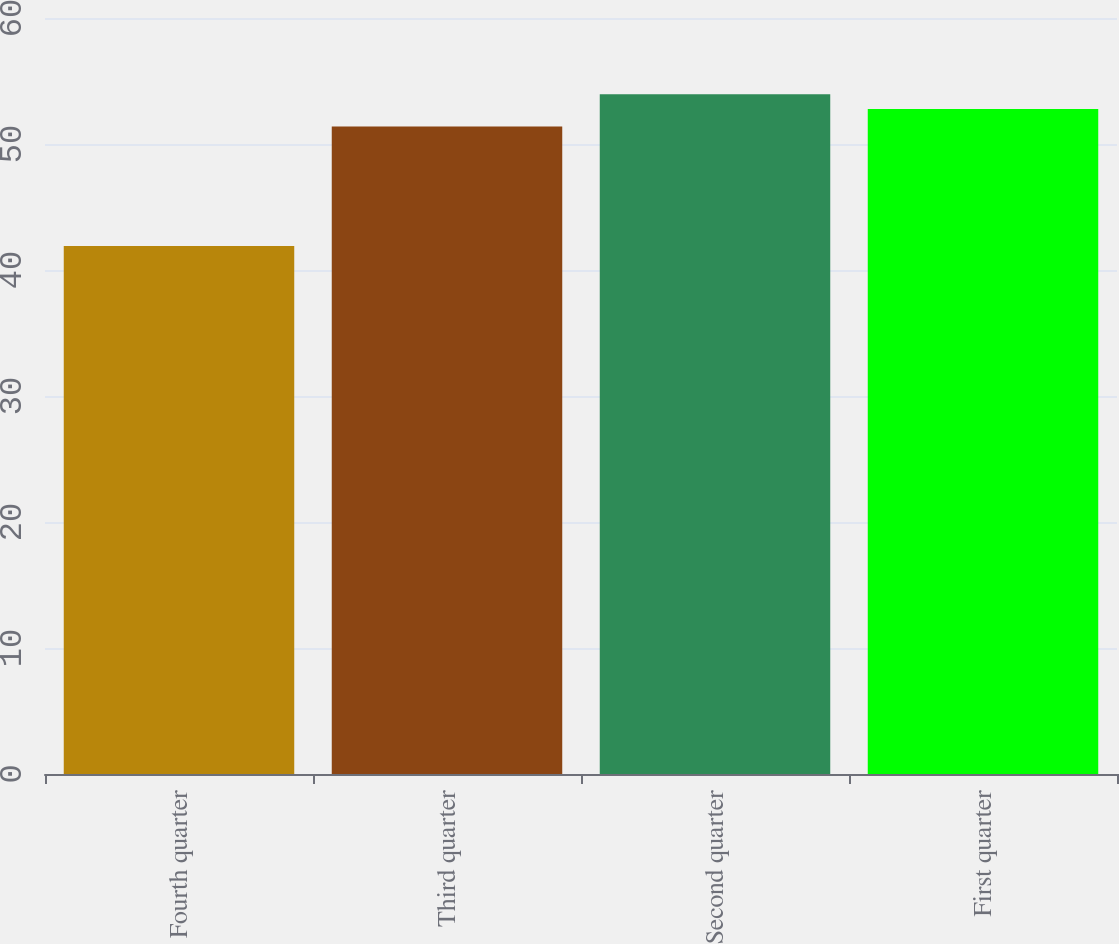Convert chart to OTSL. <chart><loc_0><loc_0><loc_500><loc_500><bar_chart><fcel>Fourth quarter<fcel>Third quarter<fcel>Second quarter<fcel>First quarter<nl><fcel>41.91<fcel>51.39<fcel>53.94<fcel>52.78<nl></chart> 